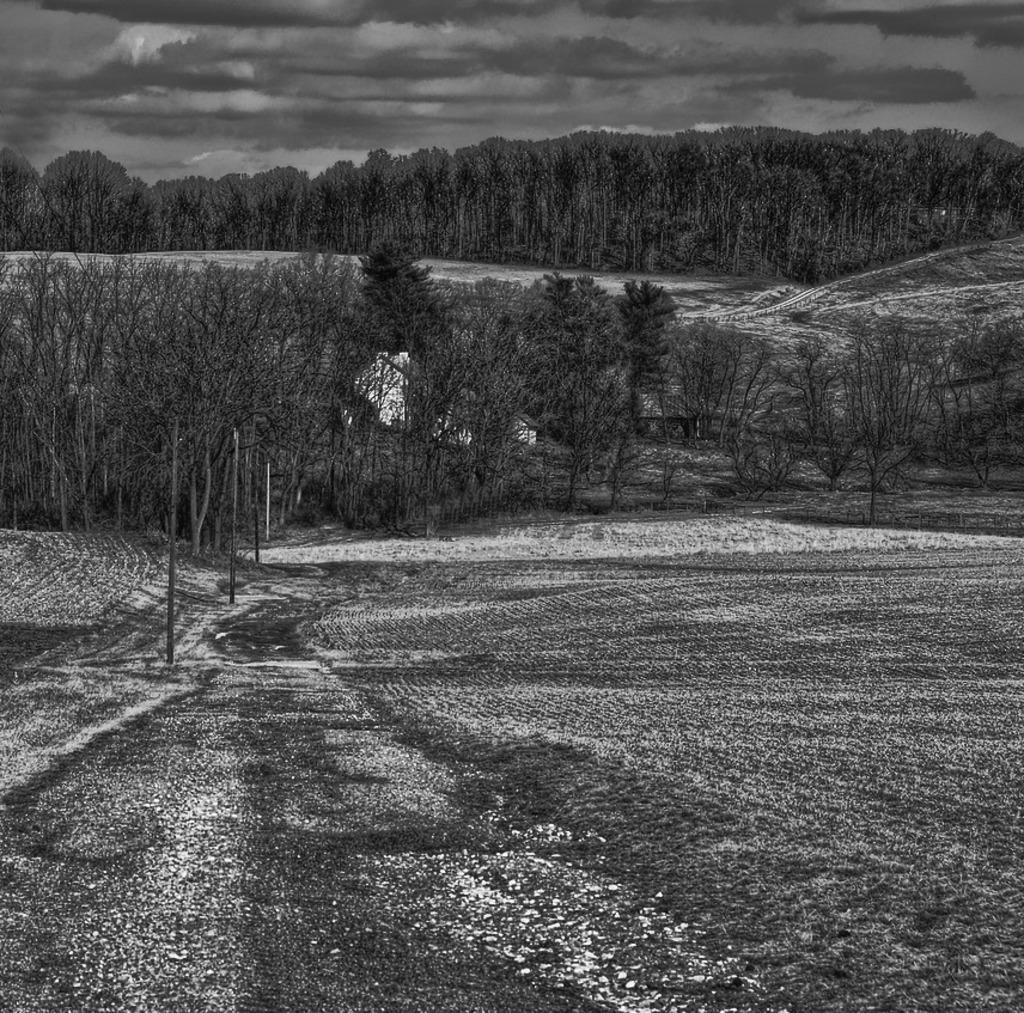What is the color scheme of the image? The image is black and white. What can be seen in the background of the image? There are many trees in the background of the image. What is located on the left side of the image? There are electric poles on the left side of the image. What is visible at the top of the image? The sky is visible in the image. What can be observed in the sky? Clouds are present in the sky. Where is the lake located in the image? There is no lake present in the image. What is the purpose of the pipe in the image? There is no pipe present in the image. 